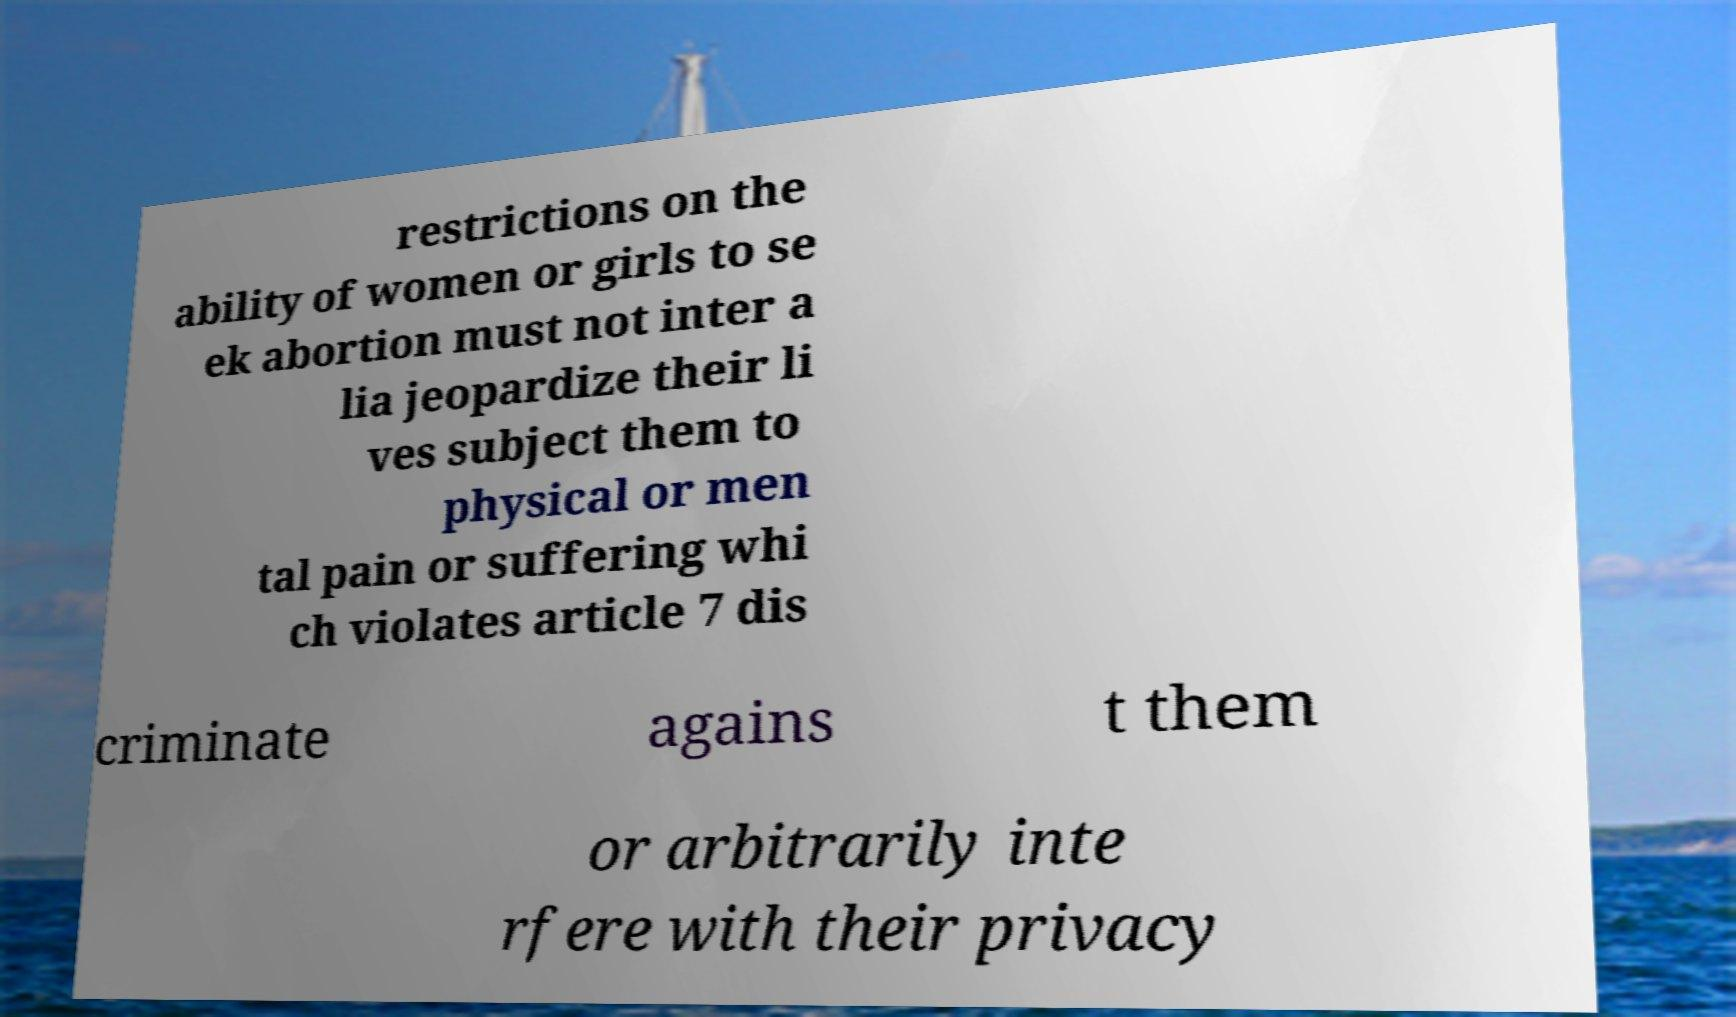I need the written content from this picture converted into text. Can you do that? restrictions on the ability of women or girls to se ek abortion must not inter a lia jeopardize their li ves subject them to physical or men tal pain or suffering whi ch violates article 7 dis criminate agains t them or arbitrarily inte rfere with their privacy 